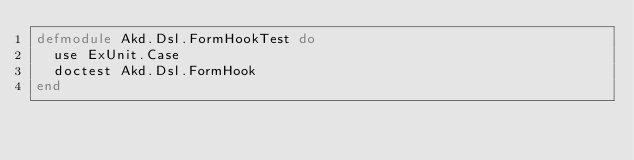<code> <loc_0><loc_0><loc_500><loc_500><_Elixir_>defmodule Akd.Dsl.FormHookTest do
  use ExUnit.Case
  doctest Akd.Dsl.FormHook
end
</code> 